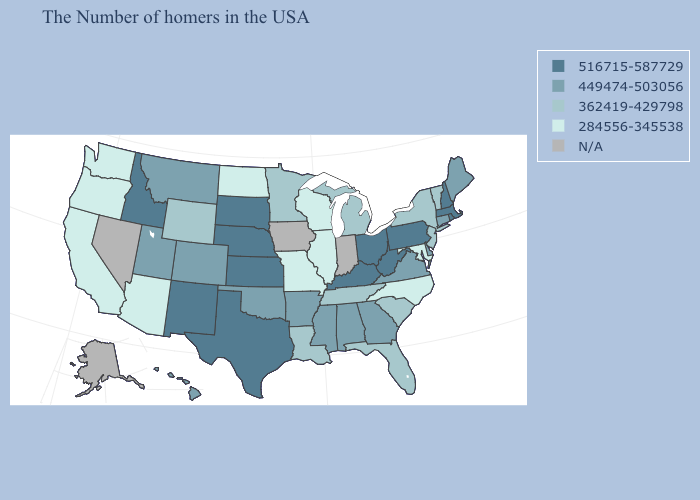What is the highest value in the MidWest ?
Write a very short answer. 516715-587729. Which states hav the highest value in the Northeast?
Short answer required. Massachusetts, Rhode Island, New Hampshire, Pennsylvania. Which states have the highest value in the USA?
Concise answer only. Massachusetts, Rhode Island, New Hampshire, Pennsylvania, West Virginia, Ohio, Kentucky, Kansas, Nebraska, Texas, South Dakota, New Mexico, Idaho. What is the highest value in the USA?
Concise answer only. 516715-587729. Among the states that border Arkansas , which have the lowest value?
Keep it brief. Missouri. How many symbols are there in the legend?
Be succinct. 5. How many symbols are there in the legend?
Give a very brief answer. 5. Name the states that have a value in the range 362419-429798?
Keep it brief. Vermont, New York, New Jersey, South Carolina, Florida, Michigan, Tennessee, Louisiana, Minnesota, Wyoming. Name the states that have a value in the range 449474-503056?
Keep it brief. Maine, Connecticut, Delaware, Virginia, Georgia, Alabama, Mississippi, Arkansas, Oklahoma, Colorado, Utah, Montana, Hawaii. Does the first symbol in the legend represent the smallest category?
Quick response, please. No. What is the value of Minnesota?
Quick response, please. 362419-429798. What is the lowest value in states that border Nebraska?
Short answer required. 284556-345538. What is the lowest value in states that border Illinois?
Give a very brief answer. 284556-345538. Does the first symbol in the legend represent the smallest category?
Give a very brief answer. No. What is the value of Nebraska?
Quick response, please. 516715-587729. 